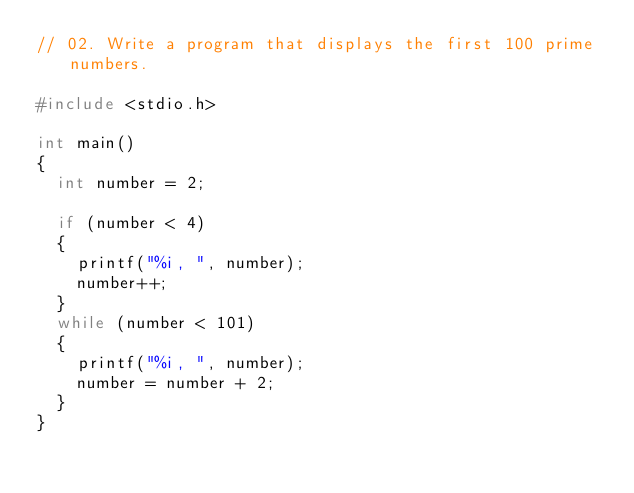<code> <loc_0><loc_0><loc_500><loc_500><_C_>// 02. Write a program that displays the first 100 prime numbers.

#include <stdio.h>

int main()
{
	int number = 2;

	if (number < 4)
	{
		printf("%i, ", number);
		number++;
	}
	while (number < 101)
	{
		printf("%i, ", number);
		number = number + 2;
	}
}</code> 